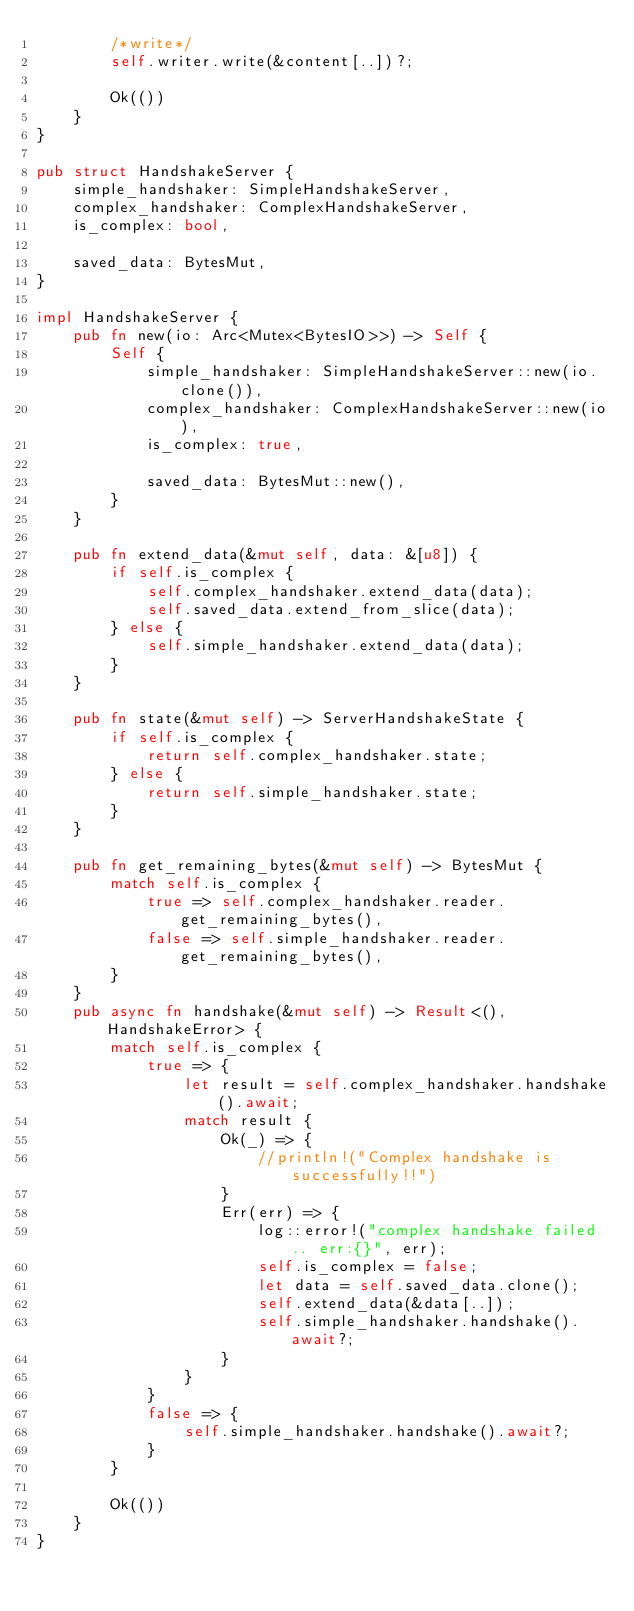Convert code to text. <code><loc_0><loc_0><loc_500><loc_500><_Rust_>        /*write*/
        self.writer.write(&content[..])?;

        Ok(())
    }
}

pub struct HandshakeServer {
    simple_handshaker: SimpleHandshakeServer,
    complex_handshaker: ComplexHandshakeServer,
    is_complex: bool,

    saved_data: BytesMut,
}

impl HandshakeServer {
    pub fn new(io: Arc<Mutex<BytesIO>>) -> Self {
        Self {
            simple_handshaker: SimpleHandshakeServer::new(io.clone()),
            complex_handshaker: ComplexHandshakeServer::new(io),
            is_complex: true,

            saved_data: BytesMut::new(),
        }
    }

    pub fn extend_data(&mut self, data: &[u8]) {
        if self.is_complex {
            self.complex_handshaker.extend_data(data);
            self.saved_data.extend_from_slice(data);
        } else {
            self.simple_handshaker.extend_data(data);
        }
    }

    pub fn state(&mut self) -> ServerHandshakeState {
        if self.is_complex {
            return self.complex_handshaker.state;
        } else {
            return self.simple_handshaker.state;
        }
    }

    pub fn get_remaining_bytes(&mut self) -> BytesMut {
        match self.is_complex {
            true => self.complex_handshaker.reader.get_remaining_bytes(),
            false => self.simple_handshaker.reader.get_remaining_bytes(),
        }
    }
    pub async fn handshake(&mut self) -> Result<(), HandshakeError> {
        match self.is_complex {
            true => {
                let result = self.complex_handshaker.handshake().await;
                match result {
                    Ok(_) => {
                        //println!("Complex handshake is successfully!!")
                    }
                    Err(err) => {
                        log::error!("complex handshake failed.. err:{}", err);
                        self.is_complex = false;
                        let data = self.saved_data.clone();
                        self.extend_data(&data[..]);
                        self.simple_handshaker.handshake().await?;
                    }
                }
            }
            false => {
                self.simple_handshaker.handshake().await?;
            }
        }

        Ok(())
    }
}
</code> 